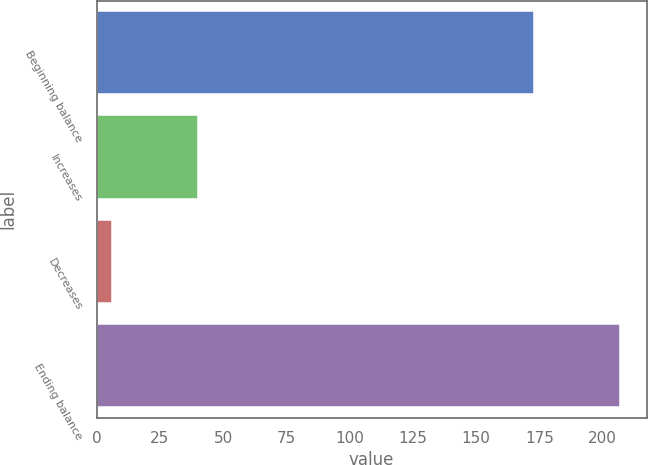Convert chart to OTSL. <chart><loc_0><loc_0><loc_500><loc_500><bar_chart><fcel>Beginning balance<fcel>Increases<fcel>Decreases<fcel>Ending balance<nl><fcel>173<fcel>40<fcel>6<fcel>207<nl></chart> 